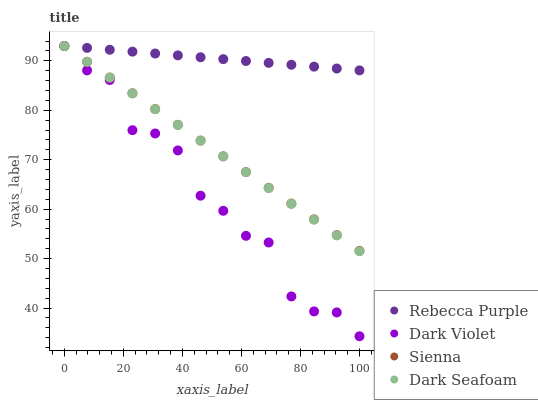Does Dark Violet have the minimum area under the curve?
Answer yes or no. Yes. Does Rebecca Purple have the maximum area under the curve?
Answer yes or no. Yes. Does Dark Seafoam have the minimum area under the curve?
Answer yes or no. No. Does Dark Seafoam have the maximum area under the curve?
Answer yes or no. No. Is Rebecca Purple the smoothest?
Answer yes or no. Yes. Is Dark Violet the roughest?
Answer yes or no. Yes. Is Dark Seafoam the smoothest?
Answer yes or no. No. Is Dark Seafoam the roughest?
Answer yes or no. No. Does Dark Violet have the lowest value?
Answer yes or no. Yes. Does Dark Seafoam have the lowest value?
Answer yes or no. No. Does Dark Violet have the highest value?
Answer yes or no. Yes. Does Dark Violet intersect Rebecca Purple?
Answer yes or no. Yes. Is Dark Violet less than Rebecca Purple?
Answer yes or no. No. Is Dark Violet greater than Rebecca Purple?
Answer yes or no. No. 